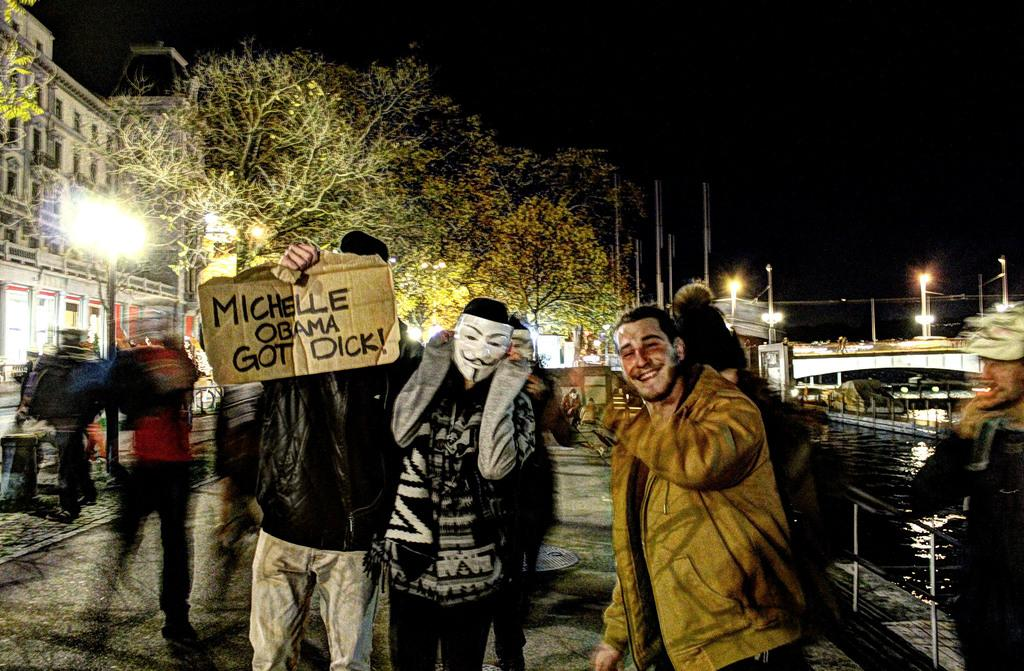How many people can be seen in the image? There are people in the image, but the exact number is not specified. What is the material of the sheet visible in the image? The sheet in the image is made of cardboard. What are the people wearing to protect themselves in the image? Face masks are present in the image, which suggests that the people are wearing them. What can be seen in the water in the image? The facts do not specify what can be seen in the water. What type of barrier is present in the image? Fences are present in the image. What structure connects two areas in the image? There is a bridge in the image. What type of vertical structures are visible in the image? Light poles are visible in the image. What type of vegetation is present in the image? Trees are present in the image. What type of man-made structures are visible in the image? Buildings are visible in the image. What are the unspecified objects in the image? The facts do not specify the nature of the unspecified objects. What is the lighting condition in the image? The background of the image is dark. What time of day is represented by the hour hand on the statement in the image? There is no statement or hour hand present in the image. Can you describe the type of fly that is resting on the bridge in the image? There are no flies present in the image. 